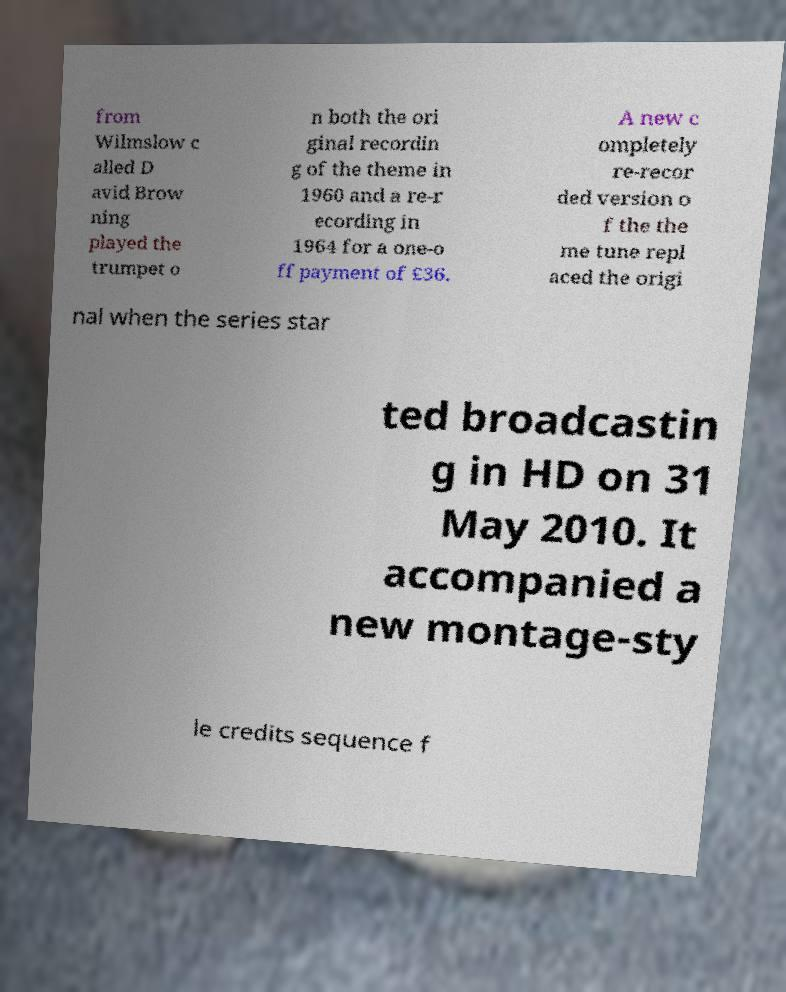There's text embedded in this image that I need extracted. Can you transcribe it verbatim? from Wilmslow c alled D avid Brow ning played the trumpet o n both the ori ginal recordin g of the theme in 1960 and a re-r ecording in 1964 for a one-o ff payment of £36. A new c ompletely re-recor ded version o f the the me tune repl aced the origi nal when the series star ted broadcastin g in HD on 31 May 2010. It accompanied a new montage-sty le credits sequence f 